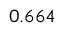Convert formula to latex. <formula><loc_0><loc_0><loc_500><loc_500>{ 0 . 6 6 4 }</formula> 